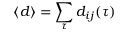Convert formula to latex. <formula><loc_0><loc_0><loc_500><loc_500>\langle d \rangle = \sum _ { \tau } d _ { i j } ( \tau )</formula> 